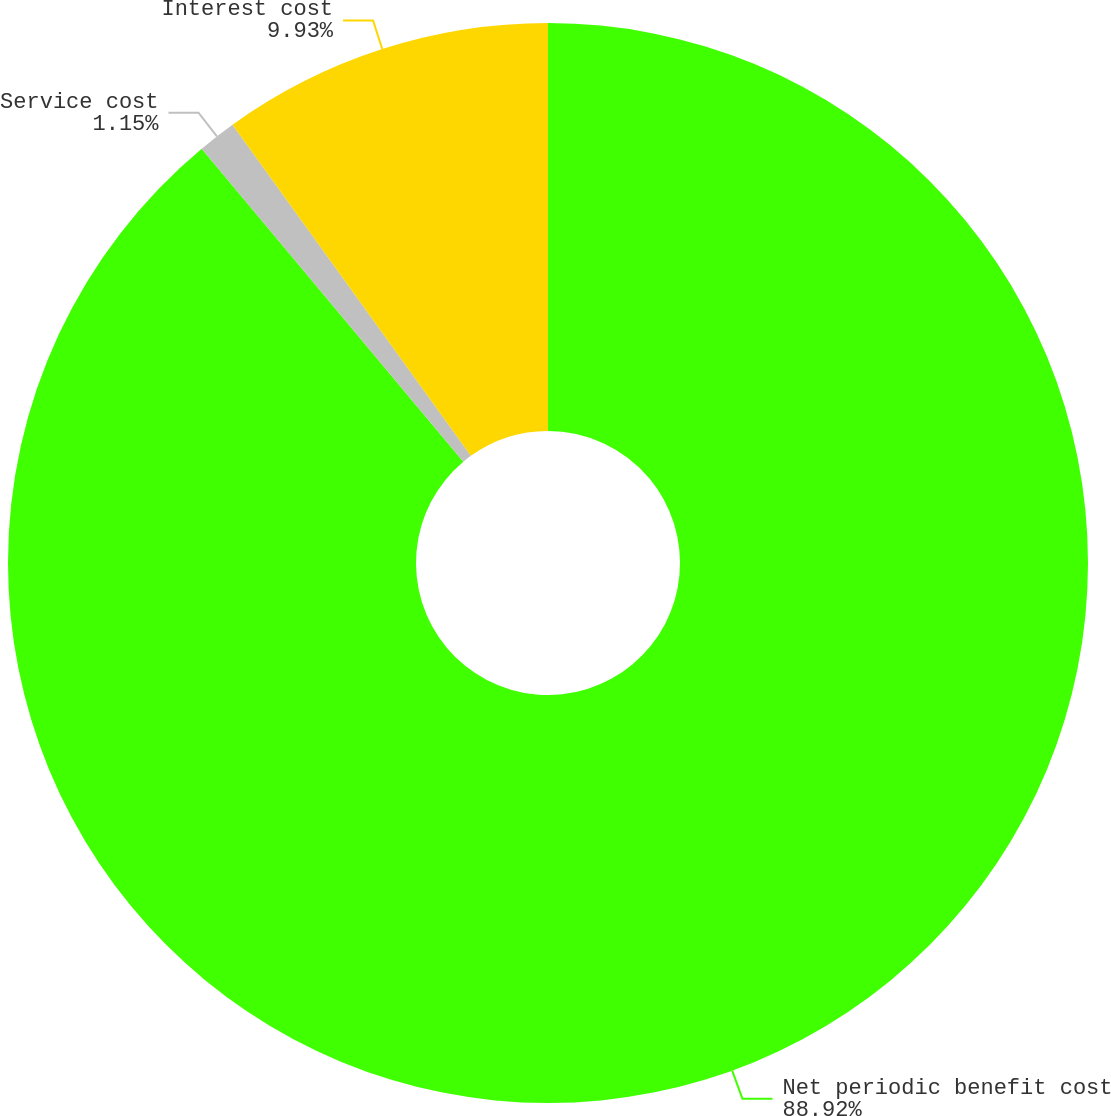Convert chart to OTSL. <chart><loc_0><loc_0><loc_500><loc_500><pie_chart><fcel>Net periodic benefit cost<fcel>Service cost<fcel>Interest cost<nl><fcel>88.92%<fcel>1.15%<fcel>9.93%<nl></chart> 